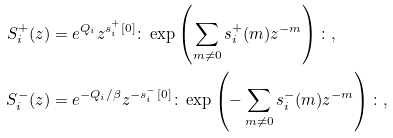Convert formula to latex. <formula><loc_0><loc_0><loc_500><loc_500>S _ { i } ^ { + } ( z ) & = e ^ { Q _ { i } } z ^ { s ^ { + } _ { i } [ 0 ] } \colon \exp \left ( \sum _ { m \neq 0 } s ^ { + } _ { i } ( m ) z ^ { - m } \right ) \colon , \\ S _ { i } ^ { - } ( z ) & = e ^ { - Q _ { i } / \beta } z ^ { - s ^ { - } _ { i } [ 0 ] } \colon \exp \left ( - \sum _ { m \neq 0 } s ^ { - } _ { i } ( m ) z ^ { - m } \right ) \colon ,</formula> 